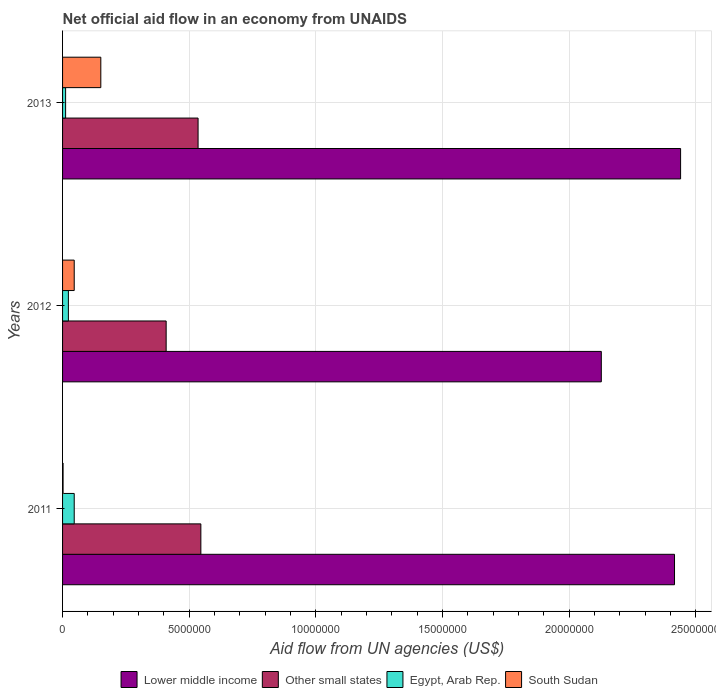How many groups of bars are there?
Your answer should be very brief. 3. Are the number of bars per tick equal to the number of legend labels?
Provide a succinct answer. Yes. How many bars are there on the 3rd tick from the top?
Your response must be concise. 4. In how many cases, is the number of bars for a given year not equal to the number of legend labels?
Your response must be concise. 0. What is the net official aid flow in Egypt, Arab Rep. in 2011?
Provide a succinct answer. 4.60e+05. Across all years, what is the maximum net official aid flow in Lower middle income?
Offer a very short reply. 2.44e+07. Across all years, what is the minimum net official aid flow in South Sudan?
Make the answer very short. 2.00e+04. In which year was the net official aid flow in Lower middle income maximum?
Your answer should be very brief. 2013. What is the total net official aid flow in Other small states in the graph?
Provide a short and direct response. 1.49e+07. What is the difference between the net official aid flow in Lower middle income in 2012 and that in 2013?
Ensure brevity in your answer.  -3.13e+06. What is the difference between the net official aid flow in Lower middle income in 2011 and the net official aid flow in Other small states in 2013?
Offer a terse response. 1.88e+07. What is the average net official aid flow in Lower middle income per year?
Your response must be concise. 2.33e+07. In the year 2012, what is the difference between the net official aid flow in Other small states and net official aid flow in South Sudan?
Offer a very short reply. 3.63e+06. In how many years, is the net official aid flow in Egypt, Arab Rep. greater than 24000000 US$?
Ensure brevity in your answer.  0. What is the ratio of the net official aid flow in South Sudan in 2012 to that in 2013?
Provide a short and direct response. 0.3. What is the difference between the highest and the second highest net official aid flow in South Sudan?
Ensure brevity in your answer.  1.05e+06. What is the difference between the highest and the lowest net official aid flow in Other small states?
Your answer should be very brief. 1.37e+06. In how many years, is the net official aid flow in Egypt, Arab Rep. greater than the average net official aid flow in Egypt, Arab Rep. taken over all years?
Make the answer very short. 1. What does the 4th bar from the top in 2012 represents?
Your response must be concise. Lower middle income. What does the 1st bar from the bottom in 2013 represents?
Your answer should be compact. Lower middle income. How many years are there in the graph?
Provide a short and direct response. 3. Are the values on the major ticks of X-axis written in scientific E-notation?
Provide a short and direct response. No. Does the graph contain grids?
Provide a succinct answer. Yes. Where does the legend appear in the graph?
Make the answer very short. Bottom center. How are the legend labels stacked?
Offer a very short reply. Horizontal. What is the title of the graph?
Provide a succinct answer. Net official aid flow in an economy from UNAIDS. Does "Angola" appear as one of the legend labels in the graph?
Your response must be concise. No. What is the label or title of the X-axis?
Provide a short and direct response. Aid flow from UN agencies (US$). What is the label or title of the Y-axis?
Offer a very short reply. Years. What is the Aid flow from UN agencies (US$) of Lower middle income in 2011?
Make the answer very short. 2.42e+07. What is the Aid flow from UN agencies (US$) of Other small states in 2011?
Provide a short and direct response. 5.46e+06. What is the Aid flow from UN agencies (US$) of Egypt, Arab Rep. in 2011?
Your answer should be very brief. 4.60e+05. What is the Aid flow from UN agencies (US$) of Lower middle income in 2012?
Offer a terse response. 2.13e+07. What is the Aid flow from UN agencies (US$) in Other small states in 2012?
Give a very brief answer. 4.09e+06. What is the Aid flow from UN agencies (US$) in Lower middle income in 2013?
Offer a very short reply. 2.44e+07. What is the Aid flow from UN agencies (US$) of Other small states in 2013?
Offer a very short reply. 5.35e+06. What is the Aid flow from UN agencies (US$) in South Sudan in 2013?
Your answer should be compact. 1.51e+06. Across all years, what is the maximum Aid flow from UN agencies (US$) in Lower middle income?
Make the answer very short. 2.44e+07. Across all years, what is the maximum Aid flow from UN agencies (US$) of Other small states?
Provide a succinct answer. 5.46e+06. Across all years, what is the maximum Aid flow from UN agencies (US$) of South Sudan?
Make the answer very short. 1.51e+06. Across all years, what is the minimum Aid flow from UN agencies (US$) in Lower middle income?
Your response must be concise. 2.13e+07. Across all years, what is the minimum Aid flow from UN agencies (US$) in Other small states?
Make the answer very short. 4.09e+06. Across all years, what is the minimum Aid flow from UN agencies (US$) in Egypt, Arab Rep.?
Your answer should be very brief. 1.20e+05. What is the total Aid flow from UN agencies (US$) of Lower middle income in the graph?
Provide a short and direct response. 6.98e+07. What is the total Aid flow from UN agencies (US$) of Other small states in the graph?
Your answer should be very brief. 1.49e+07. What is the total Aid flow from UN agencies (US$) of Egypt, Arab Rep. in the graph?
Provide a short and direct response. 8.10e+05. What is the total Aid flow from UN agencies (US$) in South Sudan in the graph?
Provide a succinct answer. 1.99e+06. What is the difference between the Aid flow from UN agencies (US$) in Lower middle income in 2011 and that in 2012?
Ensure brevity in your answer.  2.89e+06. What is the difference between the Aid flow from UN agencies (US$) of Other small states in 2011 and that in 2012?
Your answer should be very brief. 1.37e+06. What is the difference between the Aid flow from UN agencies (US$) of South Sudan in 2011 and that in 2012?
Ensure brevity in your answer.  -4.40e+05. What is the difference between the Aid flow from UN agencies (US$) in Lower middle income in 2011 and that in 2013?
Your answer should be compact. -2.40e+05. What is the difference between the Aid flow from UN agencies (US$) in Egypt, Arab Rep. in 2011 and that in 2013?
Provide a short and direct response. 3.40e+05. What is the difference between the Aid flow from UN agencies (US$) in South Sudan in 2011 and that in 2013?
Make the answer very short. -1.49e+06. What is the difference between the Aid flow from UN agencies (US$) of Lower middle income in 2012 and that in 2013?
Make the answer very short. -3.13e+06. What is the difference between the Aid flow from UN agencies (US$) of Other small states in 2012 and that in 2013?
Your answer should be very brief. -1.26e+06. What is the difference between the Aid flow from UN agencies (US$) of Egypt, Arab Rep. in 2012 and that in 2013?
Ensure brevity in your answer.  1.10e+05. What is the difference between the Aid flow from UN agencies (US$) of South Sudan in 2012 and that in 2013?
Your answer should be very brief. -1.05e+06. What is the difference between the Aid flow from UN agencies (US$) of Lower middle income in 2011 and the Aid flow from UN agencies (US$) of Other small states in 2012?
Ensure brevity in your answer.  2.01e+07. What is the difference between the Aid flow from UN agencies (US$) of Lower middle income in 2011 and the Aid flow from UN agencies (US$) of Egypt, Arab Rep. in 2012?
Your answer should be compact. 2.39e+07. What is the difference between the Aid flow from UN agencies (US$) in Lower middle income in 2011 and the Aid flow from UN agencies (US$) in South Sudan in 2012?
Provide a short and direct response. 2.37e+07. What is the difference between the Aid flow from UN agencies (US$) in Other small states in 2011 and the Aid flow from UN agencies (US$) in Egypt, Arab Rep. in 2012?
Keep it short and to the point. 5.23e+06. What is the difference between the Aid flow from UN agencies (US$) in Egypt, Arab Rep. in 2011 and the Aid flow from UN agencies (US$) in South Sudan in 2012?
Provide a succinct answer. 0. What is the difference between the Aid flow from UN agencies (US$) of Lower middle income in 2011 and the Aid flow from UN agencies (US$) of Other small states in 2013?
Ensure brevity in your answer.  1.88e+07. What is the difference between the Aid flow from UN agencies (US$) of Lower middle income in 2011 and the Aid flow from UN agencies (US$) of Egypt, Arab Rep. in 2013?
Make the answer very short. 2.40e+07. What is the difference between the Aid flow from UN agencies (US$) of Lower middle income in 2011 and the Aid flow from UN agencies (US$) of South Sudan in 2013?
Your answer should be very brief. 2.26e+07. What is the difference between the Aid flow from UN agencies (US$) in Other small states in 2011 and the Aid flow from UN agencies (US$) in Egypt, Arab Rep. in 2013?
Give a very brief answer. 5.34e+06. What is the difference between the Aid flow from UN agencies (US$) in Other small states in 2011 and the Aid flow from UN agencies (US$) in South Sudan in 2013?
Provide a succinct answer. 3.95e+06. What is the difference between the Aid flow from UN agencies (US$) of Egypt, Arab Rep. in 2011 and the Aid flow from UN agencies (US$) of South Sudan in 2013?
Offer a terse response. -1.05e+06. What is the difference between the Aid flow from UN agencies (US$) of Lower middle income in 2012 and the Aid flow from UN agencies (US$) of Other small states in 2013?
Ensure brevity in your answer.  1.59e+07. What is the difference between the Aid flow from UN agencies (US$) in Lower middle income in 2012 and the Aid flow from UN agencies (US$) in Egypt, Arab Rep. in 2013?
Provide a succinct answer. 2.12e+07. What is the difference between the Aid flow from UN agencies (US$) in Lower middle income in 2012 and the Aid flow from UN agencies (US$) in South Sudan in 2013?
Give a very brief answer. 1.98e+07. What is the difference between the Aid flow from UN agencies (US$) of Other small states in 2012 and the Aid flow from UN agencies (US$) of Egypt, Arab Rep. in 2013?
Your response must be concise. 3.97e+06. What is the difference between the Aid flow from UN agencies (US$) in Other small states in 2012 and the Aid flow from UN agencies (US$) in South Sudan in 2013?
Your response must be concise. 2.58e+06. What is the difference between the Aid flow from UN agencies (US$) of Egypt, Arab Rep. in 2012 and the Aid flow from UN agencies (US$) of South Sudan in 2013?
Your answer should be compact. -1.28e+06. What is the average Aid flow from UN agencies (US$) in Lower middle income per year?
Offer a terse response. 2.33e+07. What is the average Aid flow from UN agencies (US$) in Other small states per year?
Give a very brief answer. 4.97e+06. What is the average Aid flow from UN agencies (US$) of Egypt, Arab Rep. per year?
Offer a very short reply. 2.70e+05. What is the average Aid flow from UN agencies (US$) of South Sudan per year?
Keep it short and to the point. 6.63e+05. In the year 2011, what is the difference between the Aid flow from UN agencies (US$) in Lower middle income and Aid flow from UN agencies (US$) in Other small states?
Your answer should be compact. 1.87e+07. In the year 2011, what is the difference between the Aid flow from UN agencies (US$) in Lower middle income and Aid flow from UN agencies (US$) in Egypt, Arab Rep.?
Ensure brevity in your answer.  2.37e+07. In the year 2011, what is the difference between the Aid flow from UN agencies (US$) in Lower middle income and Aid flow from UN agencies (US$) in South Sudan?
Give a very brief answer. 2.41e+07. In the year 2011, what is the difference between the Aid flow from UN agencies (US$) of Other small states and Aid flow from UN agencies (US$) of Egypt, Arab Rep.?
Keep it short and to the point. 5.00e+06. In the year 2011, what is the difference between the Aid flow from UN agencies (US$) of Other small states and Aid flow from UN agencies (US$) of South Sudan?
Your response must be concise. 5.44e+06. In the year 2011, what is the difference between the Aid flow from UN agencies (US$) of Egypt, Arab Rep. and Aid flow from UN agencies (US$) of South Sudan?
Offer a very short reply. 4.40e+05. In the year 2012, what is the difference between the Aid flow from UN agencies (US$) in Lower middle income and Aid flow from UN agencies (US$) in Other small states?
Offer a terse response. 1.72e+07. In the year 2012, what is the difference between the Aid flow from UN agencies (US$) in Lower middle income and Aid flow from UN agencies (US$) in Egypt, Arab Rep.?
Provide a succinct answer. 2.10e+07. In the year 2012, what is the difference between the Aid flow from UN agencies (US$) of Lower middle income and Aid flow from UN agencies (US$) of South Sudan?
Provide a short and direct response. 2.08e+07. In the year 2012, what is the difference between the Aid flow from UN agencies (US$) in Other small states and Aid flow from UN agencies (US$) in Egypt, Arab Rep.?
Offer a very short reply. 3.86e+06. In the year 2012, what is the difference between the Aid flow from UN agencies (US$) of Other small states and Aid flow from UN agencies (US$) of South Sudan?
Your answer should be very brief. 3.63e+06. In the year 2012, what is the difference between the Aid flow from UN agencies (US$) in Egypt, Arab Rep. and Aid flow from UN agencies (US$) in South Sudan?
Keep it short and to the point. -2.30e+05. In the year 2013, what is the difference between the Aid flow from UN agencies (US$) in Lower middle income and Aid flow from UN agencies (US$) in Other small states?
Ensure brevity in your answer.  1.90e+07. In the year 2013, what is the difference between the Aid flow from UN agencies (US$) of Lower middle income and Aid flow from UN agencies (US$) of Egypt, Arab Rep.?
Offer a very short reply. 2.43e+07. In the year 2013, what is the difference between the Aid flow from UN agencies (US$) in Lower middle income and Aid flow from UN agencies (US$) in South Sudan?
Provide a succinct answer. 2.29e+07. In the year 2013, what is the difference between the Aid flow from UN agencies (US$) in Other small states and Aid flow from UN agencies (US$) in Egypt, Arab Rep.?
Keep it short and to the point. 5.23e+06. In the year 2013, what is the difference between the Aid flow from UN agencies (US$) in Other small states and Aid flow from UN agencies (US$) in South Sudan?
Provide a succinct answer. 3.84e+06. In the year 2013, what is the difference between the Aid flow from UN agencies (US$) in Egypt, Arab Rep. and Aid flow from UN agencies (US$) in South Sudan?
Make the answer very short. -1.39e+06. What is the ratio of the Aid flow from UN agencies (US$) in Lower middle income in 2011 to that in 2012?
Provide a short and direct response. 1.14. What is the ratio of the Aid flow from UN agencies (US$) in Other small states in 2011 to that in 2012?
Provide a short and direct response. 1.33. What is the ratio of the Aid flow from UN agencies (US$) of Egypt, Arab Rep. in 2011 to that in 2012?
Your response must be concise. 2. What is the ratio of the Aid flow from UN agencies (US$) of South Sudan in 2011 to that in 2012?
Keep it short and to the point. 0.04. What is the ratio of the Aid flow from UN agencies (US$) in Lower middle income in 2011 to that in 2013?
Offer a terse response. 0.99. What is the ratio of the Aid flow from UN agencies (US$) in Other small states in 2011 to that in 2013?
Offer a very short reply. 1.02. What is the ratio of the Aid flow from UN agencies (US$) of Egypt, Arab Rep. in 2011 to that in 2013?
Give a very brief answer. 3.83. What is the ratio of the Aid flow from UN agencies (US$) of South Sudan in 2011 to that in 2013?
Keep it short and to the point. 0.01. What is the ratio of the Aid flow from UN agencies (US$) of Lower middle income in 2012 to that in 2013?
Your answer should be very brief. 0.87. What is the ratio of the Aid flow from UN agencies (US$) in Other small states in 2012 to that in 2013?
Your answer should be very brief. 0.76. What is the ratio of the Aid flow from UN agencies (US$) of Egypt, Arab Rep. in 2012 to that in 2013?
Your answer should be very brief. 1.92. What is the ratio of the Aid flow from UN agencies (US$) of South Sudan in 2012 to that in 2013?
Offer a terse response. 0.3. What is the difference between the highest and the second highest Aid flow from UN agencies (US$) of Egypt, Arab Rep.?
Keep it short and to the point. 2.30e+05. What is the difference between the highest and the second highest Aid flow from UN agencies (US$) in South Sudan?
Your answer should be very brief. 1.05e+06. What is the difference between the highest and the lowest Aid flow from UN agencies (US$) in Lower middle income?
Your answer should be compact. 3.13e+06. What is the difference between the highest and the lowest Aid flow from UN agencies (US$) in Other small states?
Provide a succinct answer. 1.37e+06. What is the difference between the highest and the lowest Aid flow from UN agencies (US$) in Egypt, Arab Rep.?
Your answer should be very brief. 3.40e+05. What is the difference between the highest and the lowest Aid flow from UN agencies (US$) of South Sudan?
Ensure brevity in your answer.  1.49e+06. 